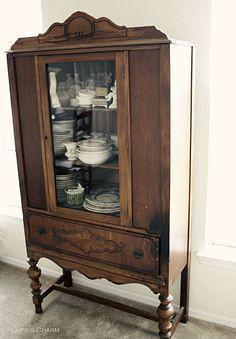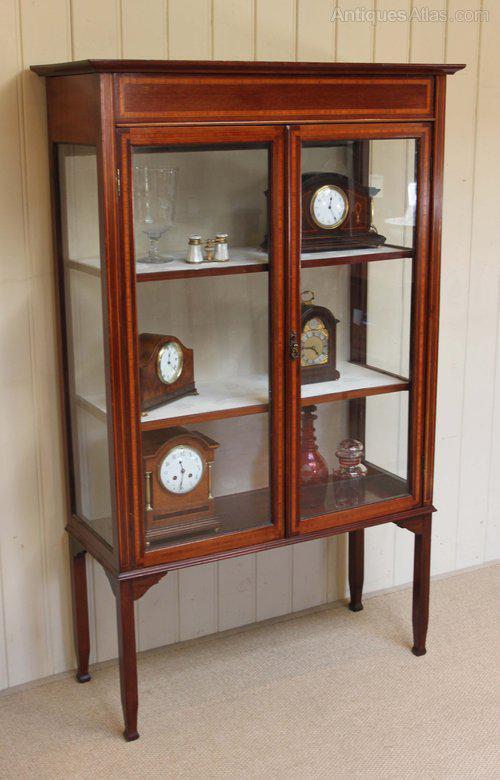The first image is the image on the left, the second image is the image on the right. Considering the images on both sides, is "One hutch has a horizontal spindle between the front legs, below a full-width drawer." valid? Answer yes or no. Yes. 